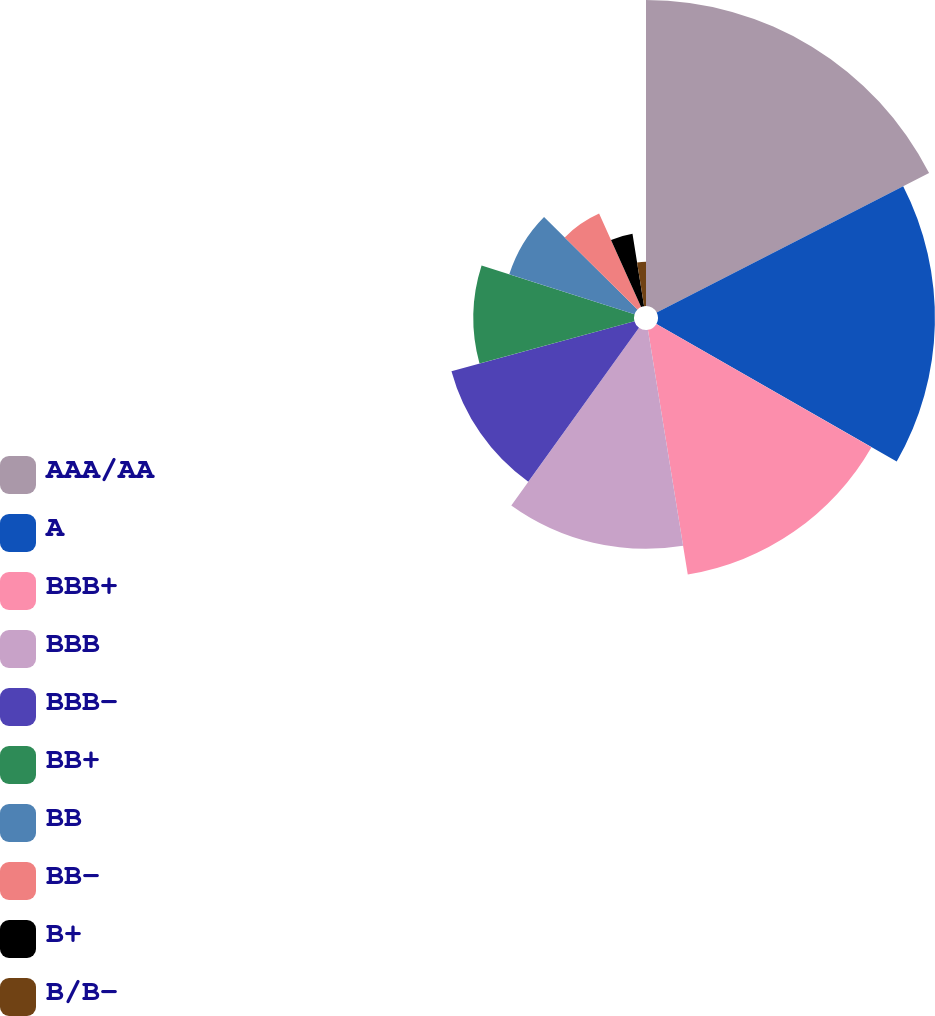<chart> <loc_0><loc_0><loc_500><loc_500><pie_chart><fcel>AAA/AA<fcel>A<fcel>BBB+<fcel>BBB<fcel>BBB-<fcel>BB+<fcel>BB<fcel>BB-<fcel>B+<fcel>B/B-<nl><fcel>17.47%<fcel>15.81%<fcel>14.15%<fcel>12.49%<fcel>10.83%<fcel>9.17%<fcel>7.51%<fcel>5.85%<fcel>4.19%<fcel>2.53%<nl></chart> 